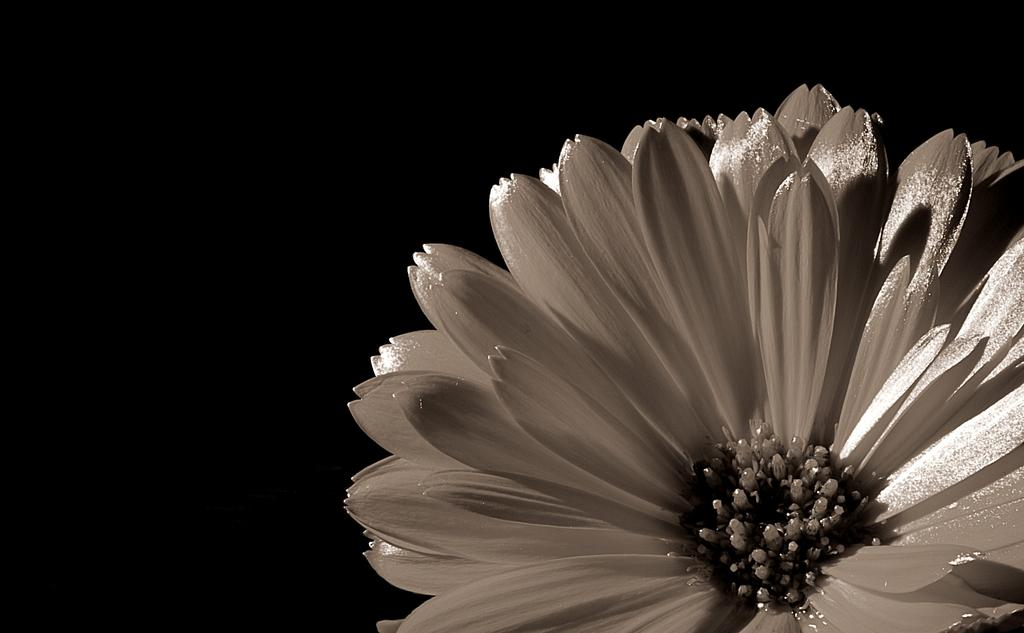What type of flower is on the right side of the image? There is a white color flower on the right side of the image. What can be observed in the background of the image? The background of the image is dark in color. What reason is given for the sea's presence in the image? There is no sea present in the image, so no reason can be given for its presence. 